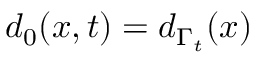Convert formula to latex. <formula><loc_0><loc_0><loc_500><loc_500>d _ { 0 } ( x , t ) = d _ { \Gamma _ { t } } ( x )</formula> 